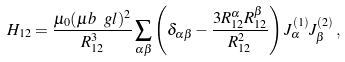Convert formula to latex. <formula><loc_0><loc_0><loc_500><loc_500>H _ { 1 2 } = \frac { \mu _ { 0 } ( \mu b \ g l ) ^ { 2 } } { R _ { 1 2 } ^ { 3 } } \sum _ { \alpha \beta } \left ( \delta _ { \alpha \beta } - \frac { 3 R _ { 1 2 } ^ { \alpha } R _ { 1 2 } ^ { \beta } } { R _ { 1 2 } ^ { 2 } } \right ) J ^ { ( 1 ) } _ { \alpha } J ^ { ( 2 ) } _ { \beta } \, ,</formula> 